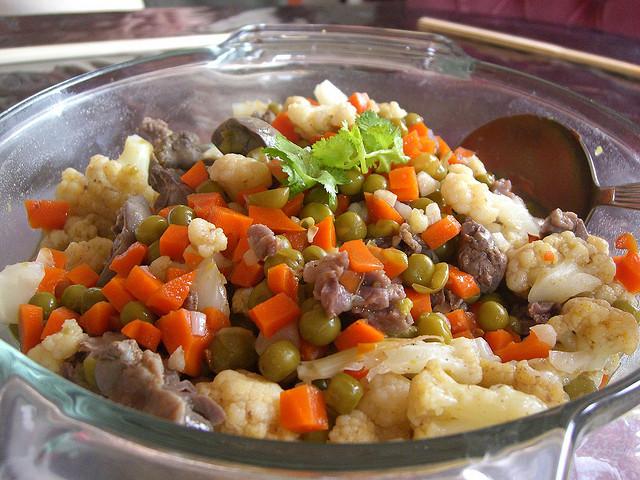Is this a vegetarian meal?
Concise answer only. No. How many different veggies are there?
Keep it brief. 4. What is in the bowl?
Write a very short answer. Vegetables. 